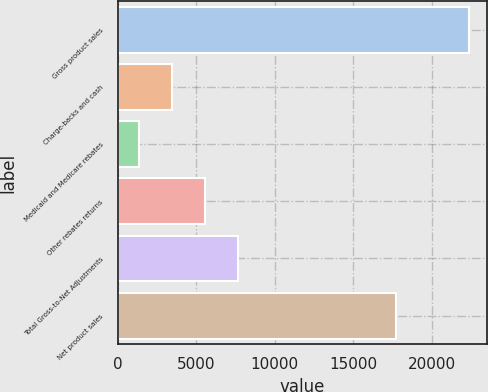Convert chart. <chart><loc_0><loc_0><loc_500><loc_500><bar_chart><fcel>Gross product sales<fcel>Charge-backs and cash<fcel>Medicaid and Medicare rebates<fcel>Other rebates returns<fcel>Total Gross-to-Net Adjustments<fcel>Net product sales<nl><fcel>22364<fcel>3480.2<fcel>1382<fcel>5578.4<fcel>7676.6<fcel>17702<nl></chart> 